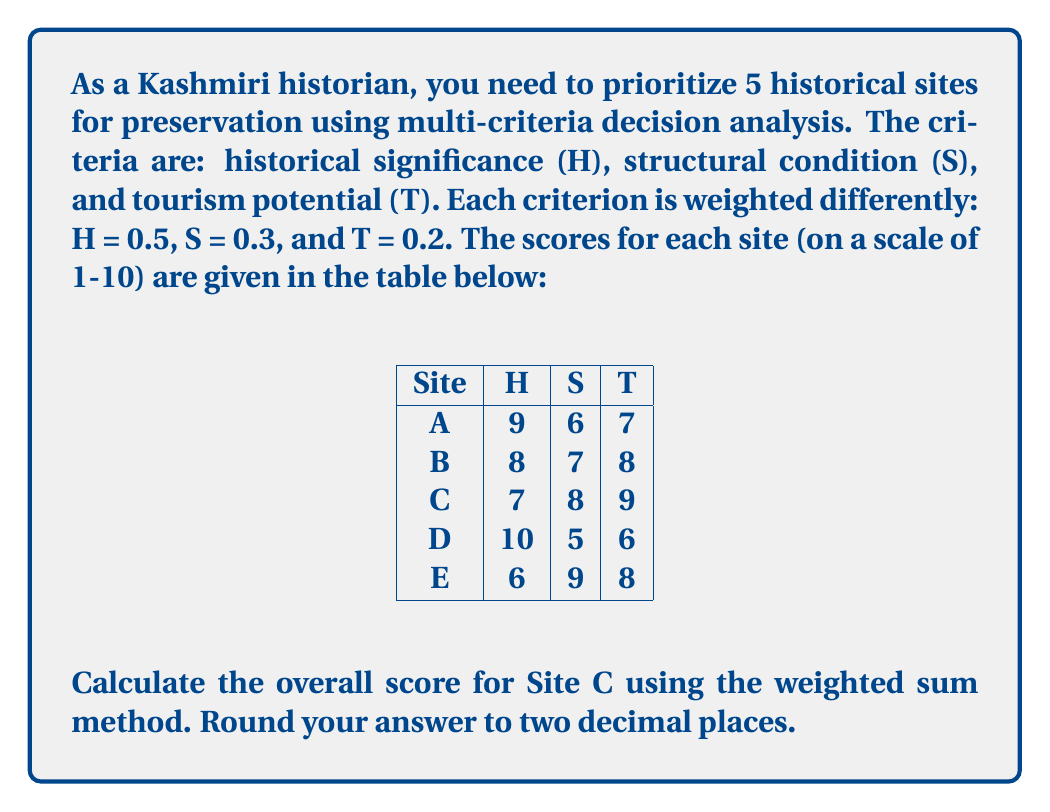Teach me how to tackle this problem. To solve this problem using multi-criteria decision analysis with the weighted sum method, we'll follow these steps:

1) First, let's identify the scores for Site C:
   Historical significance (H): 7
   Structural condition (S): 8
   Tourism potential (T): 9

2) Recall the weights for each criterion:
   H: 0.5
   S: 0.3
   T: 0.2

3) The weighted sum method calculates the overall score by multiplying each criterion score by its weight and then summing these products. We can express this mathematically as:

   $$\text{Overall Score} = \sum_{i=1}^{n} w_i \times s_i$$

   Where $w_i$ is the weight of criterion $i$, and $s_i$ is the score for criterion $i$.

4) Let's calculate:
   
   $$\begin{align*}
   \text{Overall Score} &= (0.5 \times 7) + (0.3 \times 8) + (0.2 \times 9) \\
   &= 3.5 + 2.4 + 1.8 \\
   &= 7.7
   \end{align*}$$

5) Rounding to two decimal places, we get 7.70.
Answer: 7.70 